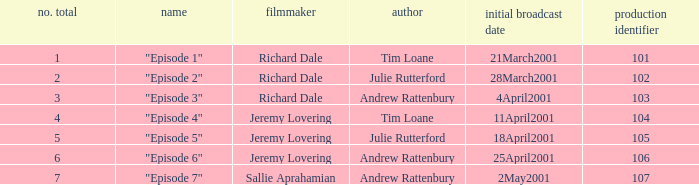What is the highest production code of an episode written by Tim Loane? 104.0. 